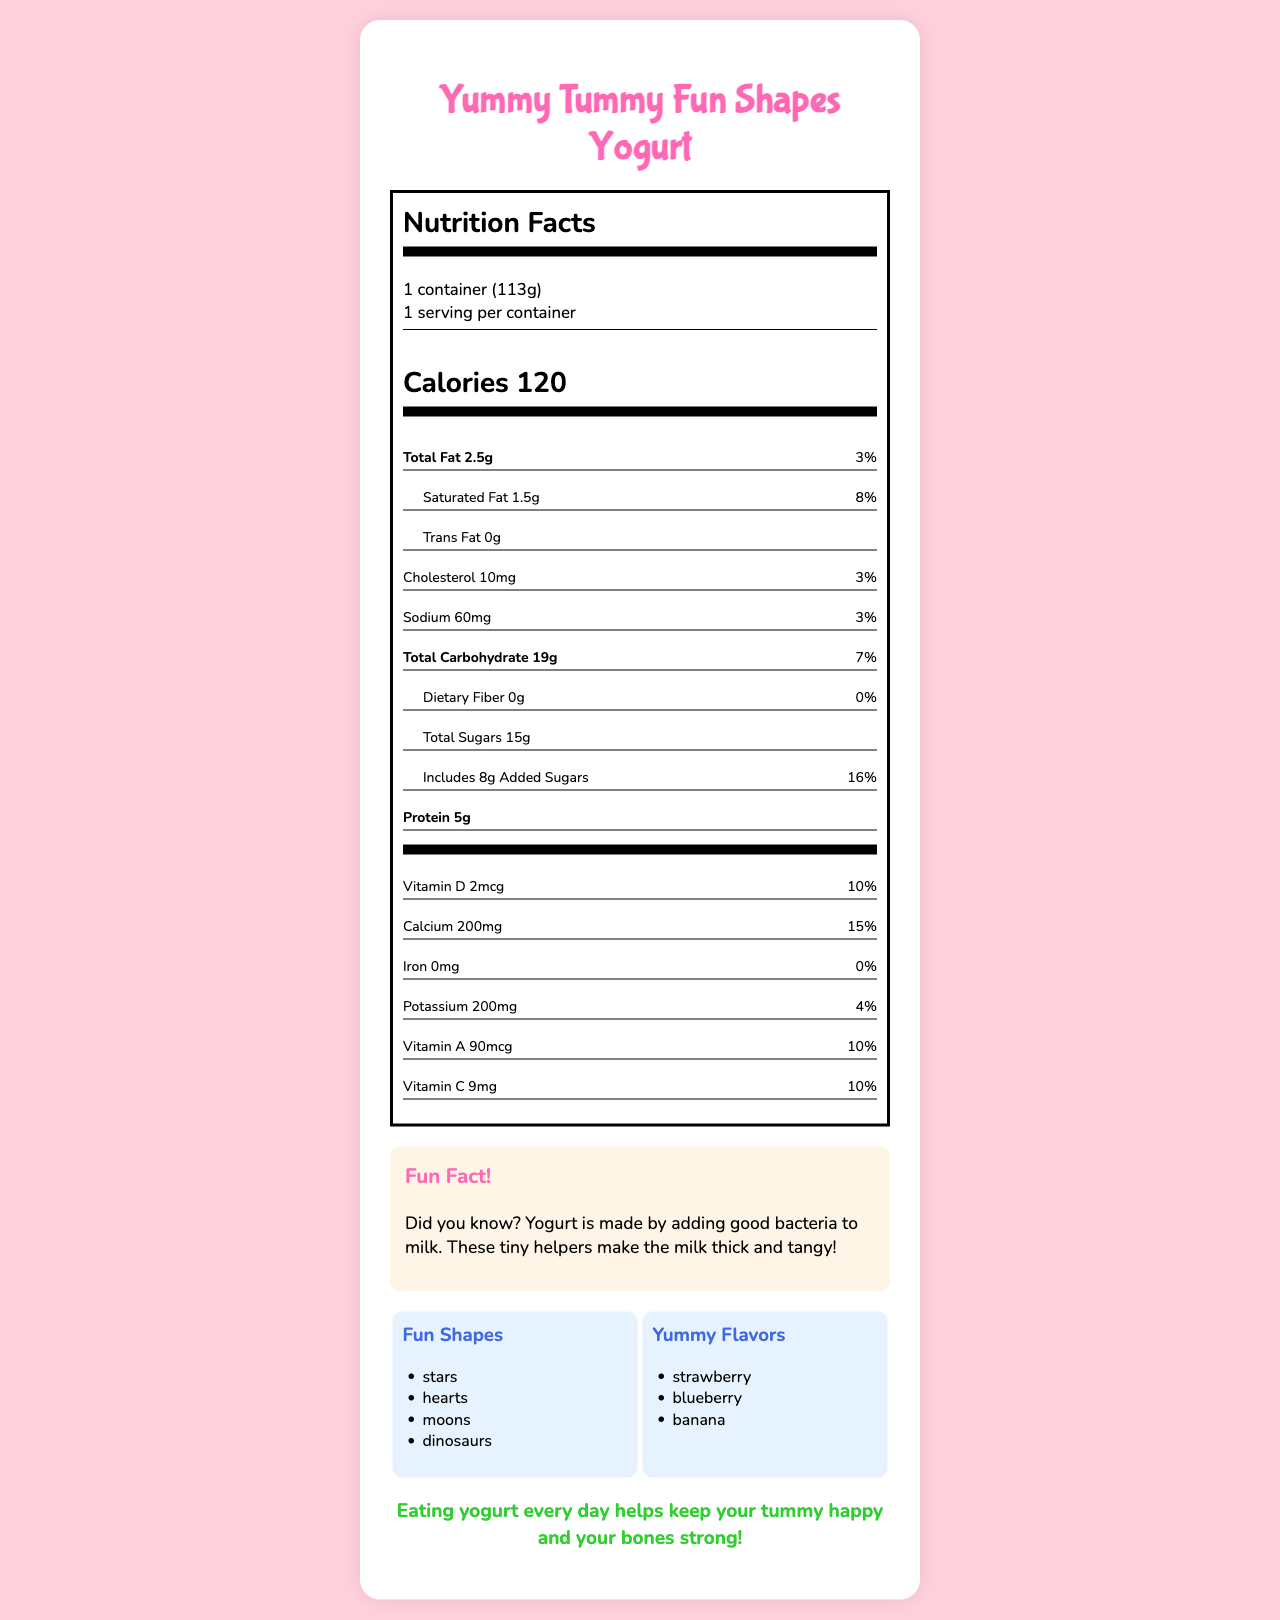What is the serving size of the Yummy Tummy Fun Shapes Yogurt? The serving size is stated directly in the document under the "serving size" section.
Answer: 1 container (113g) How many calories are in one serving of this yogurt? The calories are clearly listed in bold under the "calories" section of the nutrition label.
Answer: 120 What are the fun shapes available in the Yummy Tummy Fun Shapes Yogurt? The list of fun shapes is mentioned in the document under the "Fun Shapes" section.
Answer: Stars, hearts, moons, dinosaurs Which vitamins are added to this yogurt? The added vitamins are listed in the document under the "added vitamins" section.
Answer: B6, B12, E How much protein is in one container of this yogurt? The protein content is listed in the "protein" section of the nutrition label.
Answer: 5g What is the daily value percentage of calcium in this yogurt? The daily value percentage for calcium is provided in the "calcium" section of the nutrition label.
Answer: 15% What is the amount of added sugars in this yogurt? A. 5g B. 8g C. 10g D. 15g The amount of added sugars is clearly listed as "8g" under the "Includes Added Sugars" section of the nutrition label.
Answer: B Which of the following ingredients is not present in this yogurt? A. Pectin B. Blueberries C. Nuts D. Vitamin D3 The ingredient list mentions pectin, blueberries, and vitamin D3, but does not include nuts (though there is a warning about traces of nuts).
Answer: C Is there any information about iron content in this yogurt? The document mentions iron content as 0mg with a 0% daily value in the "iron" section of the nutrition label.
Answer: Yes Is it stated that the yogurt contains live and active cultures? The document lists live and active cultures in the ingredient section.
Answer: Yes Summarize the main idea of this document. The document's main purpose is to inform consumers about the nutritional content, fun features, ingredients, and health benefits of the Yummy Tummy Fun Shapes Yogurt.
Answer: The document provides detailed nutrition facts for "Yummy Tummy Fun Shapes Yogurt," including serving size, calories, fat, vitamins, and minerals. It also mentions fun shapes, flavors, added vitamins, allergen information, ingredients, a fun fact about yogurt, and a health message promoting its benefits. What is the temperature needed to store the Yummy Tummy Fun Shapes Yogurt? The document does not provide any information regarding the storage temperature for the yogurt.
Answer: Not enough information 